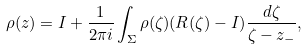Convert formula to latex. <formula><loc_0><loc_0><loc_500><loc_500>\rho ( z ) = I + \frac { 1 } { 2 \pi i } \int _ { \Sigma } \rho ( \zeta ) ( R ( \zeta ) - I ) \frac { d \zeta } { \zeta - z _ { - } } ,</formula> 